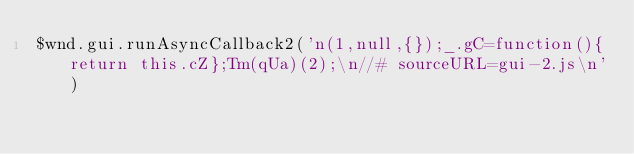<code> <loc_0><loc_0><loc_500><loc_500><_JavaScript_>$wnd.gui.runAsyncCallback2('n(1,null,{});_.gC=function(){return this.cZ};Tm(qUa)(2);\n//# sourceURL=gui-2.js\n')
</code> 